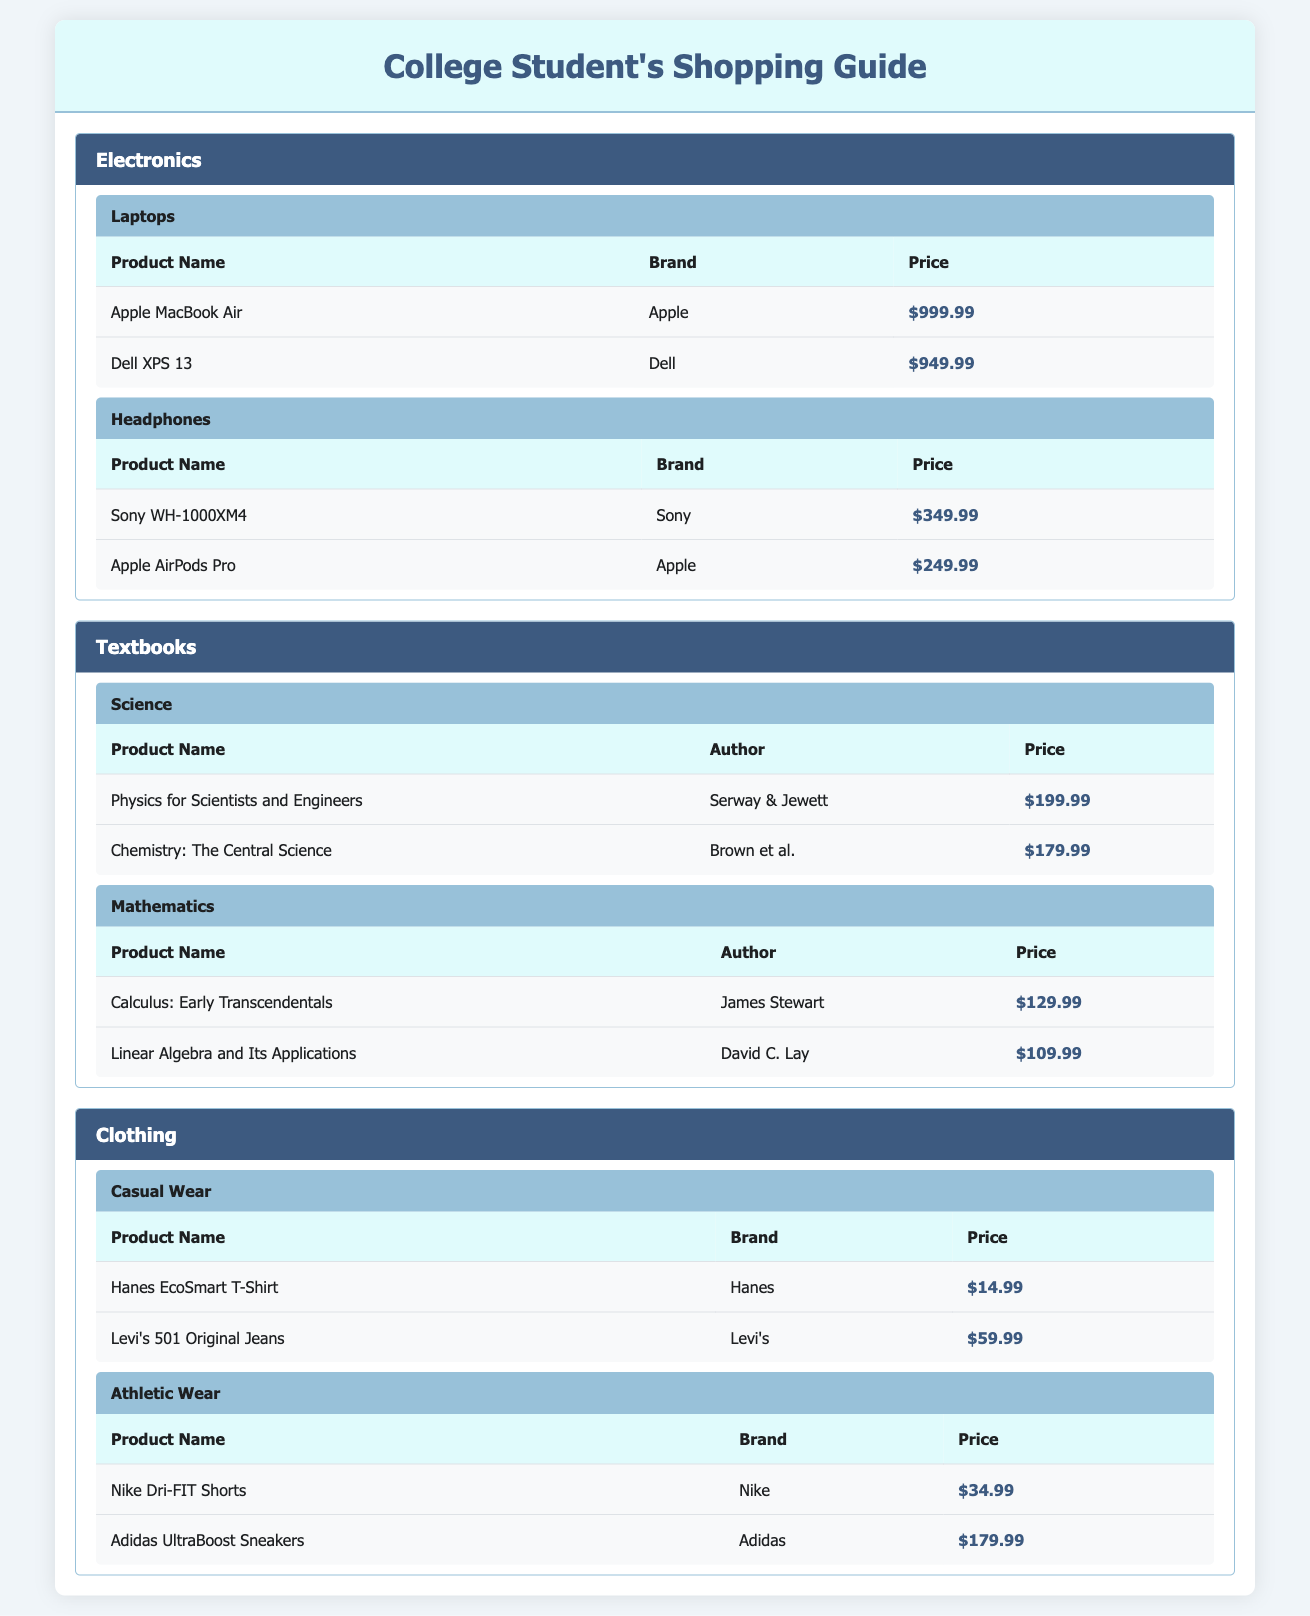What is the price of the Apple MacBook Air? The table lists the Apple MacBook Air under the Electronics category, specifically under the Laptops subcategory. The price for the Apple MacBook Air is shown as $999.99.
Answer: $999.99 What are the two authors of the textbooks listed in the Science subcategory? The Science subcategory under Textbooks contains two products: "Physics for Scientists and Engineers" authored by Serway & Jewett and "Chemistry: The Central Science" by Brown et al. Therefore, the two authors are Serway & Jewett and Brown et al.
Answer: Serway & Jewett, Brown et al How much do the two athletic wear products cost in total? The two athletic wear products listed are Nike Dri-FIT Shorts priced at $34.99 and Adidas UltraBoost Sneakers priced at $179.99. To find the total cost, sum the two prices: 34.99 + 179.99 = 214.98.
Answer: $214.98 Is there a textbook priced over $200? By scanning the table for the prices in the Textbooks category, the textbook "Physics for Scientists and Engineers" is priced at $199.99, which is not over $200. The next highest price is $179.99 for "Chemistry: The Central Science," which is also not over $200. Therefore, none of the textbooks are over $200.
Answer: No What is the average price of casual wear clothing items? The casual wear subcategory lists two products: Hanes EcoSmart T-Shirt at $14.99 and Levi's 501 Original Jeans at $59.99. First, sum the prices: 14.99 + 59.99 = 74.98. Next, divide by the number of items, which is 2: 74.98 / 2 = 37.49. Therefore, the average price of the casual wear items is $37.49.
Answer: $37.49 Which brand has the most expensive headphones listed in the table? The headphones listed are Sony WH-1000XM4 priced at $349.99 and Apple AirPods Pro priced at $249.99. Comparing the prices, the Sony WH-1000XM4 is priced higher at $349.99. Thus, the brand with the most expensive headphones is Sony.
Answer: Sony How many products are listed under the Electronics category in total? There are two subcategories under Electronics: Laptops and Headphones. Each subcategory contains two products, which gives us a total of 2 products from Laptops (Apple MacBook Air, Dell XPS 13) and 2 products from Headphones (Sony WH-1000XM4, Apple AirPods Pro). Adding these gives 2 + 2 = 4 products total.
Answer: 4 Are there any products in the Clothing category that are cheaper than $20? Looking at the Clothing category, the listed products in Casual Wear include Hanes EcoSmart T-Shirt priced at $14.99 and Levi's 501 Original Jeans at $59.99. Since $14.99 is less than $20, there is at least one product priced cheaper than $20 in the Clothing category.
Answer: Yes 